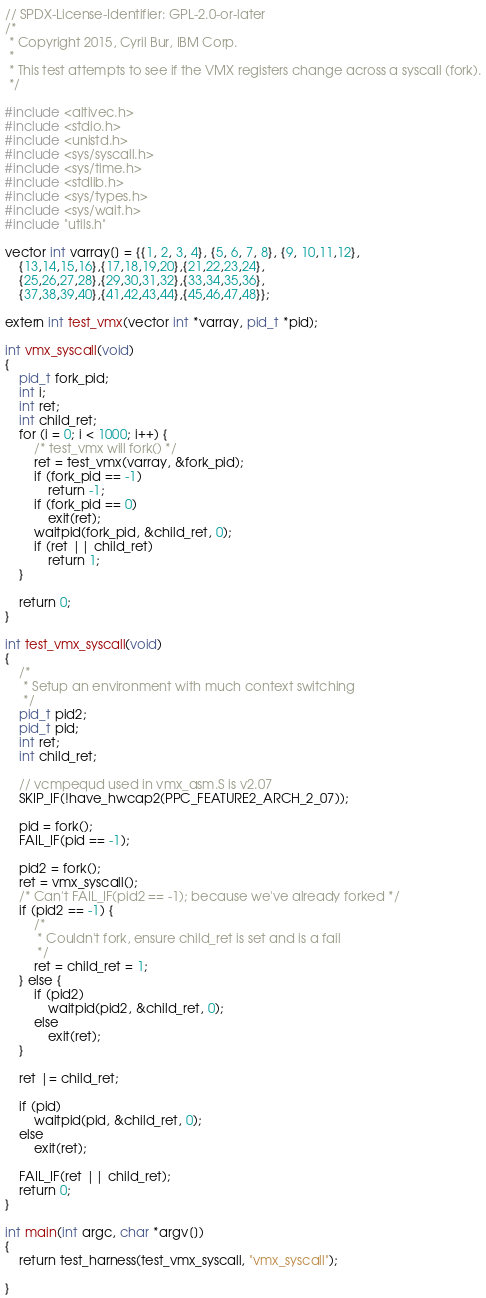<code> <loc_0><loc_0><loc_500><loc_500><_C_>// SPDX-License-Identifier: GPL-2.0-or-later
/*
 * Copyright 2015, Cyril Bur, IBM Corp.
 *
 * This test attempts to see if the VMX registers change across a syscall (fork).
 */

#include <altivec.h>
#include <stdio.h>
#include <unistd.h>
#include <sys/syscall.h>
#include <sys/time.h>
#include <stdlib.h>
#include <sys/types.h>
#include <sys/wait.h>
#include "utils.h"

vector int varray[] = {{1, 2, 3, 4}, {5, 6, 7, 8}, {9, 10,11,12},
	{13,14,15,16},{17,18,19,20},{21,22,23,24},
	{25,26,27,28},{29,30,31,32},{33,34,35,36},
	{37,38,39,40},{41,42,43,44},{45,46,47,48}};

extern int test_vmx(vector int *varray, pid_t *pid);

int vmx_syscall(void)
{
	pid_t fork_pid;
	int i;
	int ret;
	int child_ret;
	for (i = 0; i < 1000; i++) {
		/* test_vmx will fork() */
		ret = test_vmx(varray, &fork_pid);
		if (fork_pid == -1)
			return -1;
		if (fork_pid == 0)
			exit(ret);
		waitpid(fork_pid, &child_ret, 0);
		if (ret || child_ret)
			return 1;
	}

	return 0;
}

int test_vmx_syscall(void)
{
	/*
	 * Setup an environment with much context switching
	 */
	pid_t pid2;
	pid_t pid;
	int ret;
	int child_ret;

	// vcmpequd used in vmx_asm.S is v2.07
	SKIP_IF(!have_hwcap2(PPC_FEATURE2_ARCH_2_07));

	pid = fork();
	FAIL_IF(pid == -1);

	pid2 = fork();
	ret = vmx_syscall();
	/* Can't FAIL_IF(pid2 == -1); because we've already forked */
	if (pid2 == -1) {
		/*
		 * Couldn't fork, ensure child_ret is set and is a fail
		 */
		ret = child_ret = 1;
	} else {
		if (pid2)
			waitpid(pid2, &child_ret, 0);
		else
			exit(ret);
	}

	ret |= child_ret;

	if (pid)
		waitpid(pid, &child_ret, 0);
	else
		exit(ret);

	FAIL_IF(ret || child_ret);
	return 0;
}

int main(int argc, char *argv[])
{
	return test_harness(test_vmx_syscall, "vmx_syscall");

}
</code> 